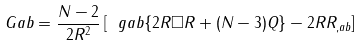Convert formula to latex. <formula><loc_0><loc_0><loc_500><loc_500>\ G a b = \frac { N - 2 } { 2 R ^ { 2 } } \left [ \ g a b \{ 2 R \Box R + ( N - 3 ) Q \} - 2 R R _ { , a b } \right ]</formula> 